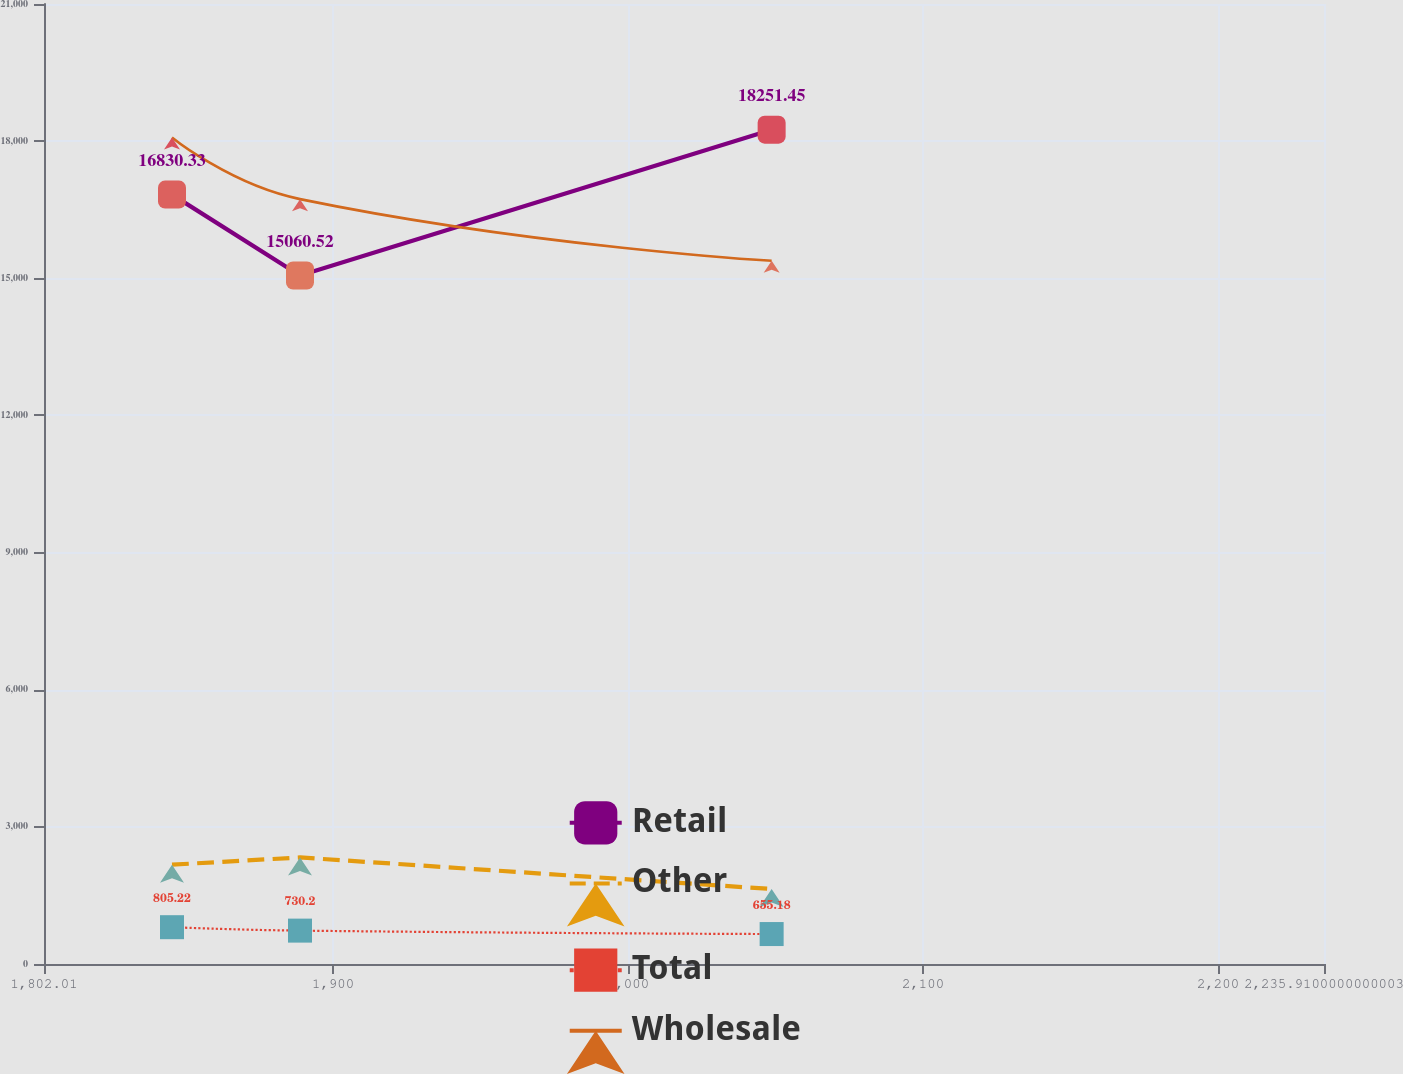<chart> <loc_0><loc_0><loc_500><loc_500><line_chart><ecel><fcel>Retail<fcel>Other<fcel>Total<fcel>Wholesale<nl><fcel>1845.4<fcel>16830.3<fcel>2172.82<fcel>805.22<fcel>18080.6<nl><fcel>1888.79<fcel>15060.5<fcel>2330.99<fcel>730.2<fcel>16731.4<nl><fcel>2048.67<fcel>18251.5<fcel>1640.17<fcel>655.18<fcel>15382.3<nl><fcel>2279.3<fcel>2810.82<fcel>697.15<fcel>29.23<fcel>3471.09<nl></chart> 